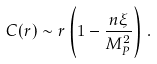Convert formula to latex. <formula><loc_0><loc_0><loc_500><loc_500>C ( r ) \sim r \left ( 1 - \frac { n \xi } { M _ { P } ^ { 2 } } \right ) \, .</formula> 